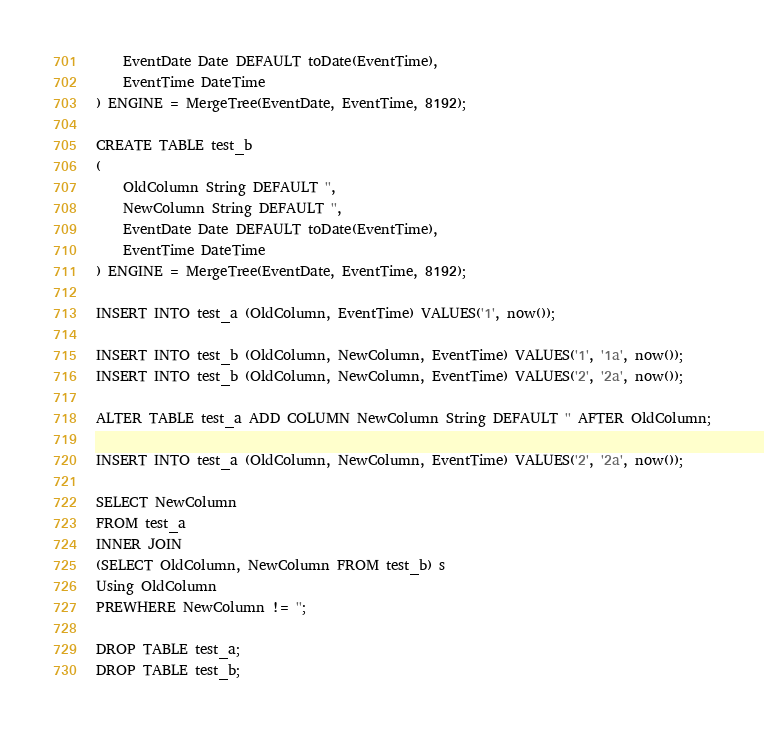Convert code to text. <code><loc_0><loc_0><loc_500><loc_500><_SQL_>    EventDate Date DEFAULT toDate(EventTime),
    EventTime DateTime
) ENGINE = MergeTree(EventDate, EventTime, 8192);

CREATE TABLE test_b
(
    OldColumn String DEFAULT '',
    NewColumn String DEFAULT '',
    EventDate Date DEFAULT toDate(EventTime),
    EventTime DateTime
) ENGINE = MergeTree(EventDate, EventTime, 8192);

INSERT INTO test_a (OldColumn, EventTime) VALUES('1', now());

INSERT INTO test_b (OldColumn, NewColumn, EventTime) VALUES('1', '1a', now());
INSERT INTO test_b (OldColumn, NewColumn, EventTime) VALUES('2', '2a', now());

ALTER TABLE test_a ADD COLUMN NewColumn String DEFAULT '' AFTER OldColumn;

INSERT INTO test_a (OldColumn, NewColumn, EventTime) VALUES('2', '2a', now());

SELECT NewColumn
FROM test_a
INNER JOIN
(SELECT OldColumn, NewColumn FROM test_b) s
Using OldColumn
PREWHERE NewColumn != '';

DROP TABLE test_a;
DROP TABLE test_b;
</code> 